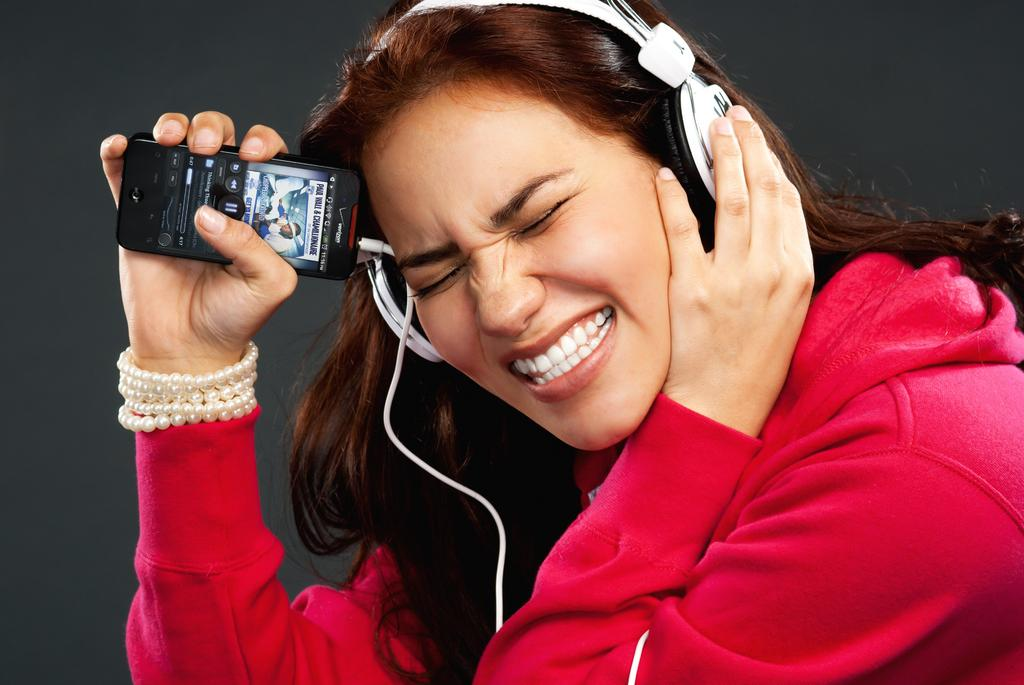Who is the main subject in the image? There is a girl in the image. What is the girl wearing on her ears? The girl is wearing a headphone. What is the girl holding in her hand? The girl is holding a phone. What color is the girl's hoodie? The girl is wearing a red hoodie. What type of apple is the girl eating during the meeting in the image? There is no apple or meeting present in the image; the girl is wearing a headphone and holding a phone. What sound does the alarm make in the image? There is no alarm present in the image; the girl is wearing a headphone and holding a phone. 